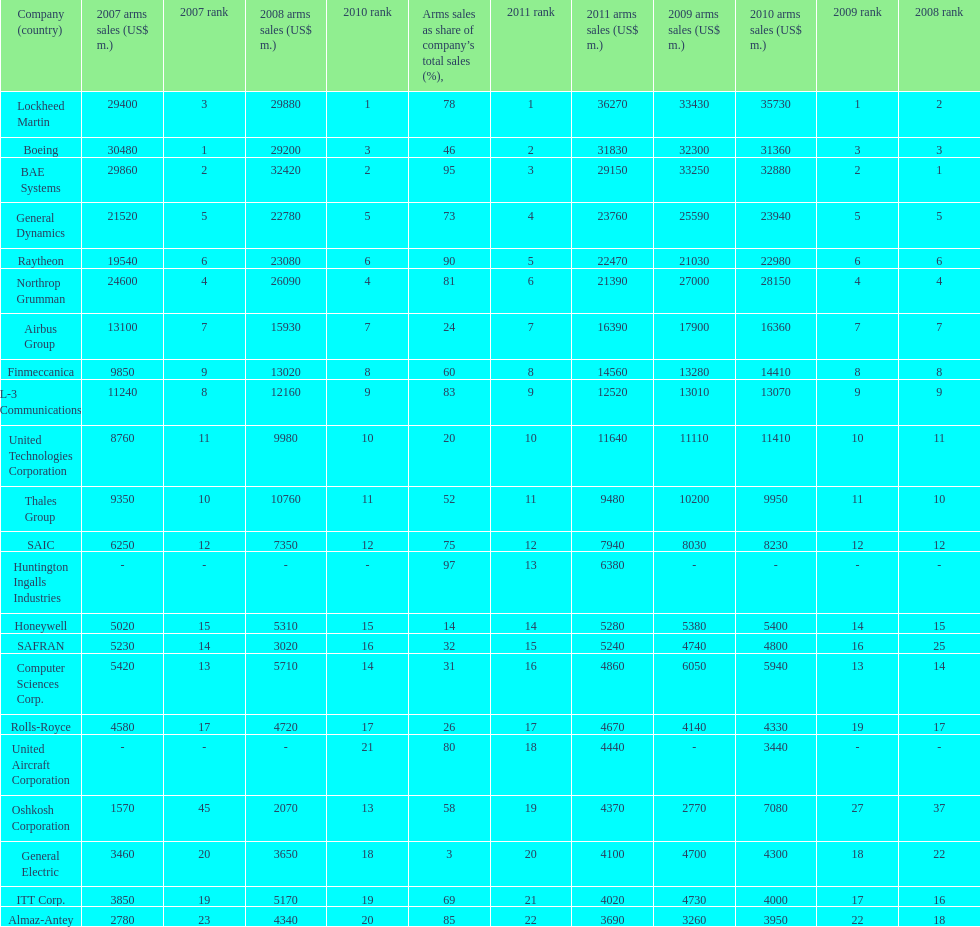How many companies are under the united states? 14. 